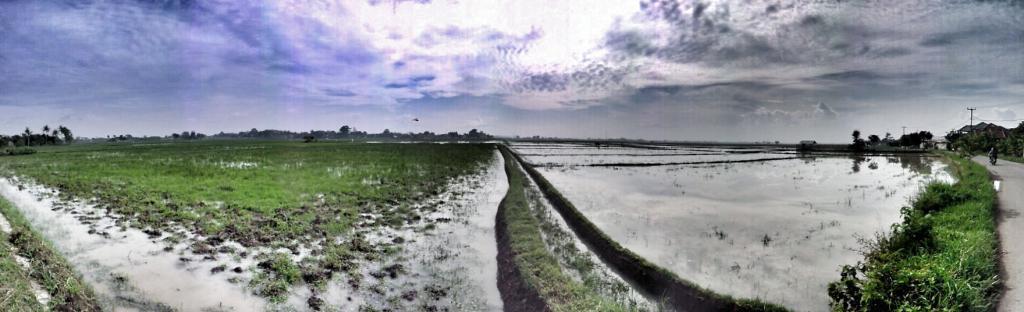How would you summarize this image in a sentence or two? In this image at the bottom there are some plants and some water, and on the right side there are some poles, trees, houses and vehicle. And on the vehicle there are some persons sitting, and at the top there is sky and in the background there are some trees. 